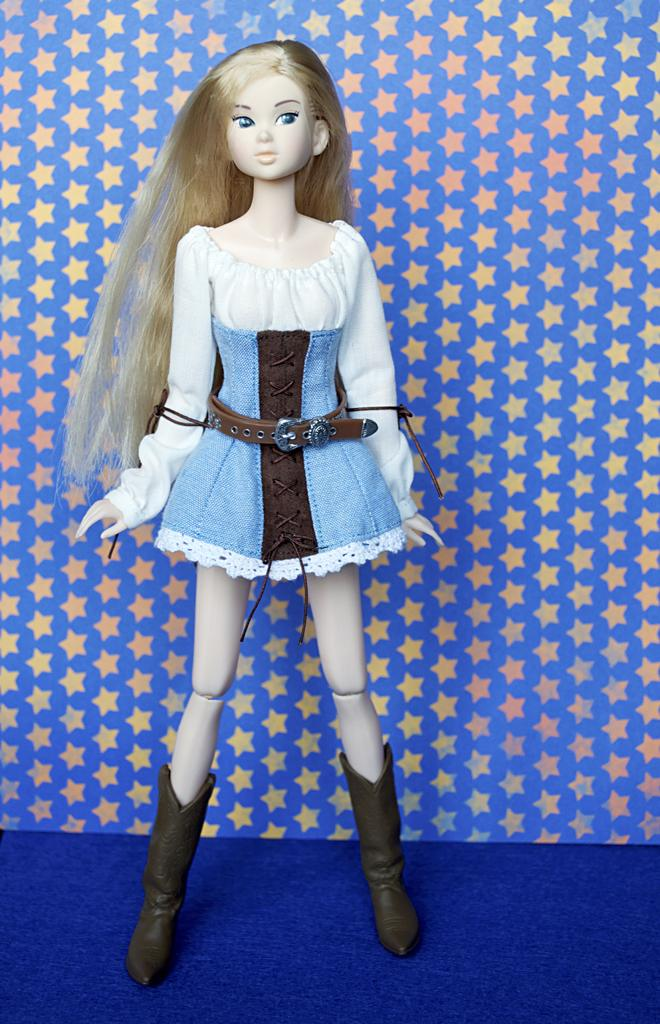What is the main subject of the image? There is a doll in the image. Where is the doll located? The doll is placed on a table. What can be seen in the background of the image? There are small stars on a paper visible in the background. What type of spoon is the doll holding in the image? There is no spoon present in the image; the doll is not holding anything. 